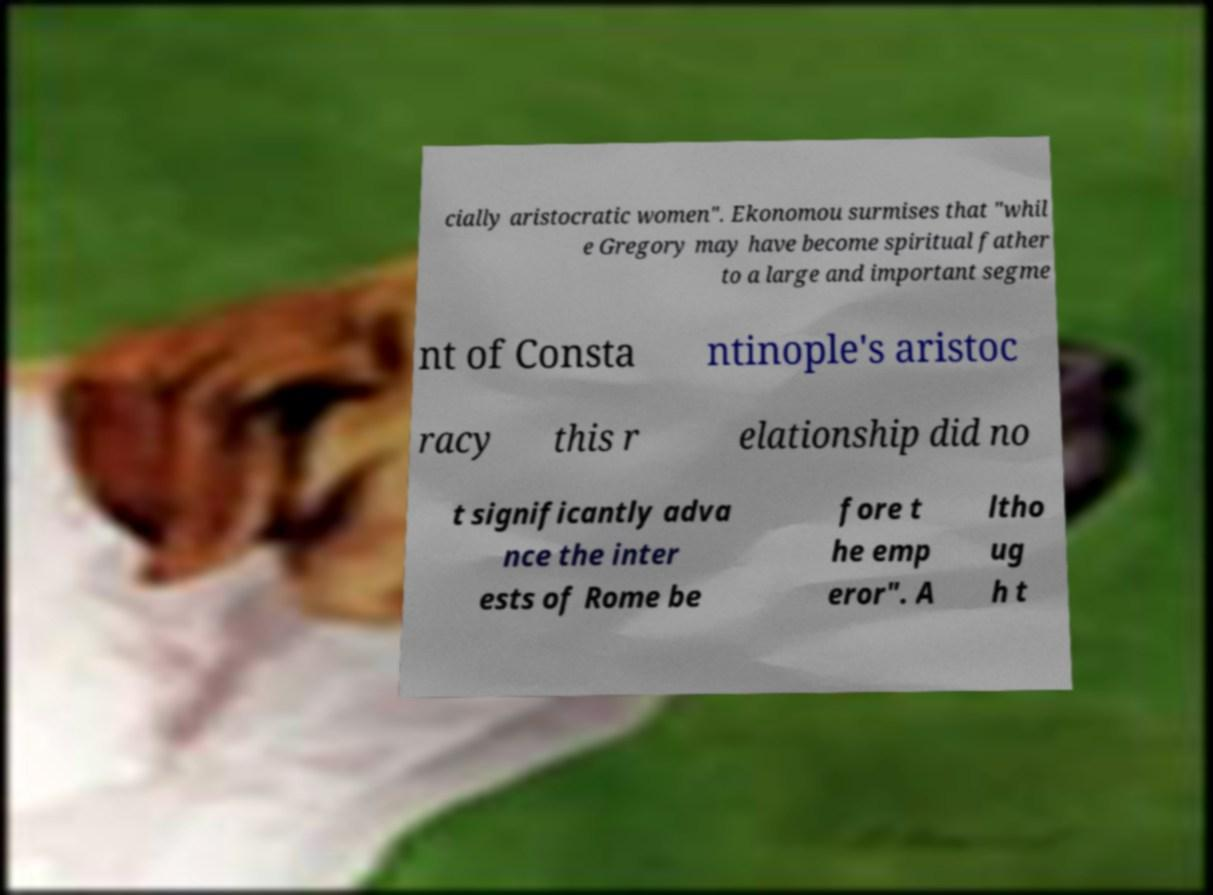Can you accurately transcribe the text from the provided image for me? cially aristocratic women". Ekonomou surmises that "whil e Gregory may have become spiritual father to a large and important segme nt of Consta ntinople's aristoc racy this r elationship did no t significantly adva nce the inter ests of Rome be fore t he emp eror". A ltho ug h t 